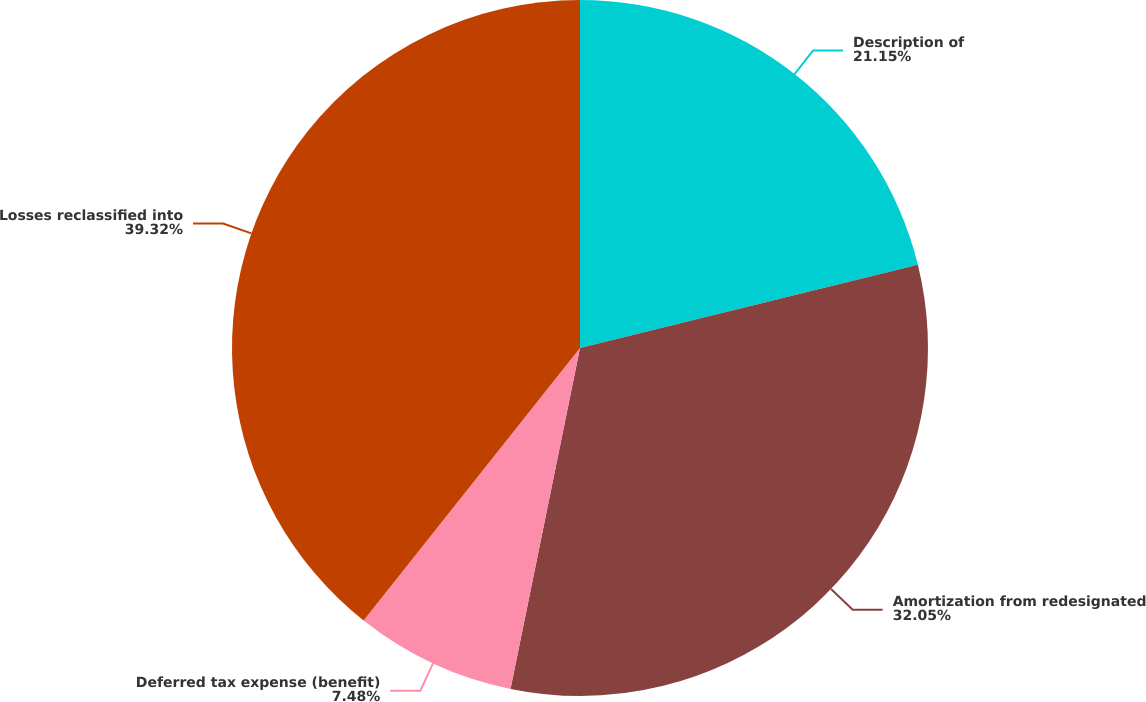Convert chart. <chart><loc_0><loc_0><loc_500><loc_500><pie_chart><fcel>Description of<fcel>Amortization from redesignated<fcel>Deferred tax expense (benefit)<fcel>Losses reclassified into<nl><fcel>21.15%<fcel>32.05%<fcel>7.48%<fcel>39.32%<nl></chart> 